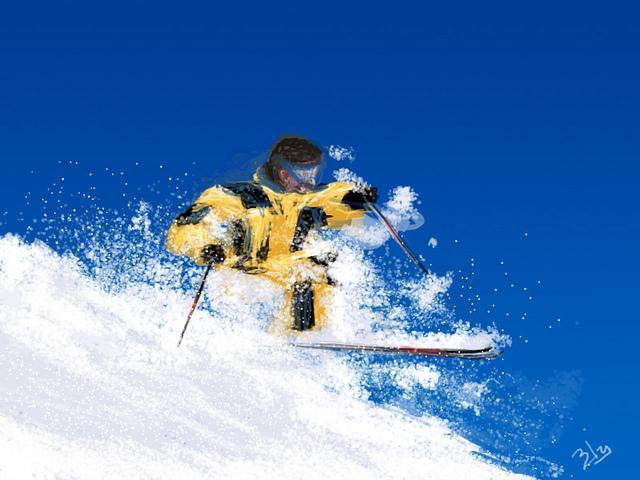How many rolls of toilet paper is in the photo?
Give a very brief answer. 0. 